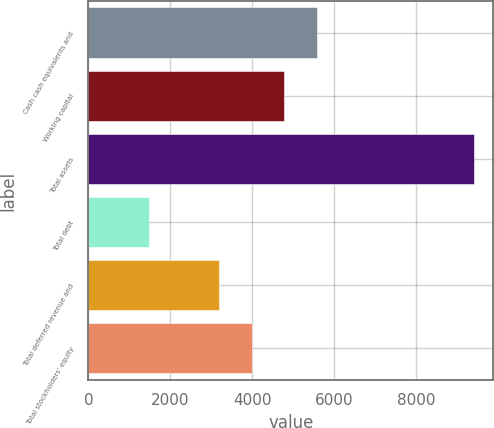<chart> <loc_0><loc_0><loc_500><loc_500><bar_chart><fcel>Cash cash equivalents and<fcel>Working capital<fcel>Total assets<fcel>Total debt<fcel>Total deferred revenue and<fcel>Total stockholders' equity<nl><fcel>5571.2<fcel>4779.8<fcel>9401<fcel>1487<fcel>3197<fcel>3988.4<nl></chart> 